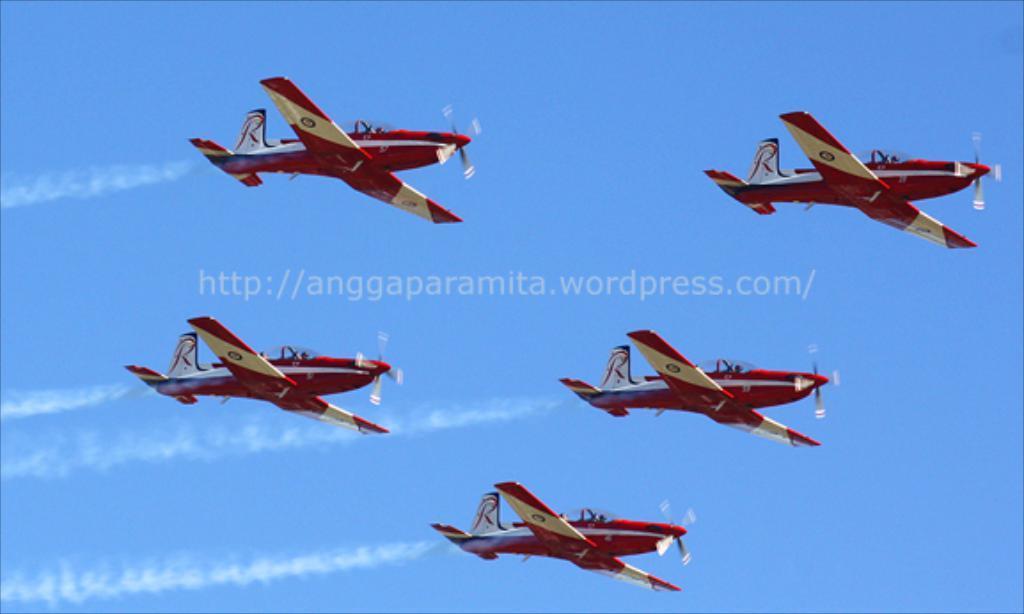Can you describe this image briefly? In the image we can see five flying jets in the sky. Here we can see the sky and the watermark in between the image. 